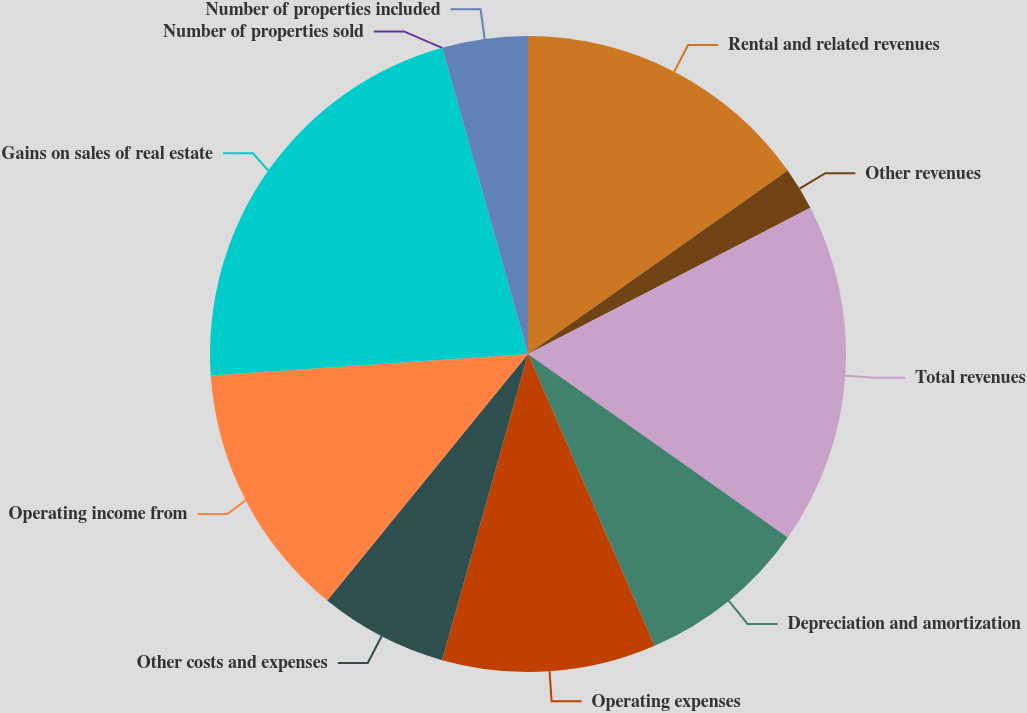<chart> <loc_0><loc_0><loc_500><loc_500><pie_chart><fcel>Rental and related revenues<fcel>Other revenues<fcel>Total revenues<fcel>Depreciation and amortization<fcel>Operating expenses<fcel>Other costs and expenses<fcel>Operating income from<fcel>Gains on sales of real estate<fcel>Number of properties sold<fcel>Number of properties included<nl><fcel>15.21%<fcel>2.18%<fcel>17.39%<fcel>8.7%<fcel>10.87%<fcel>6.52%<fcel>13.04%<fcel>21.73%<fcel>0.0%<fcel>4.35%<nl></chart> 